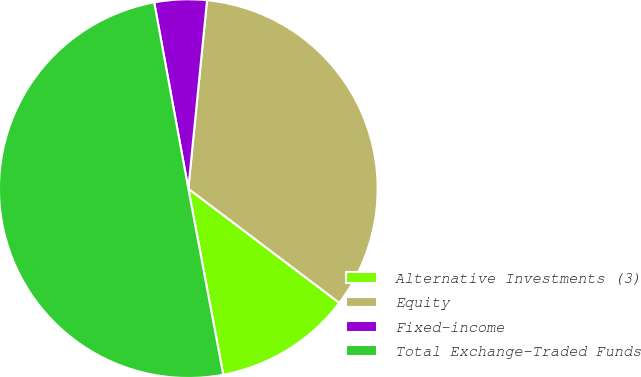Convert chart to OTSL. <chart><loc_0><loc_0><loc_500><loc_500><pie_chart><fcel>Alternative Investments (3)<fcel>Equity<fcel>Fixed-income<fcel>Total Exchange-Traded Funds<nl><fcel>11.74%<fcel>33.73%<fcel>4.46%<fcel>50.07%<nl></chart> 